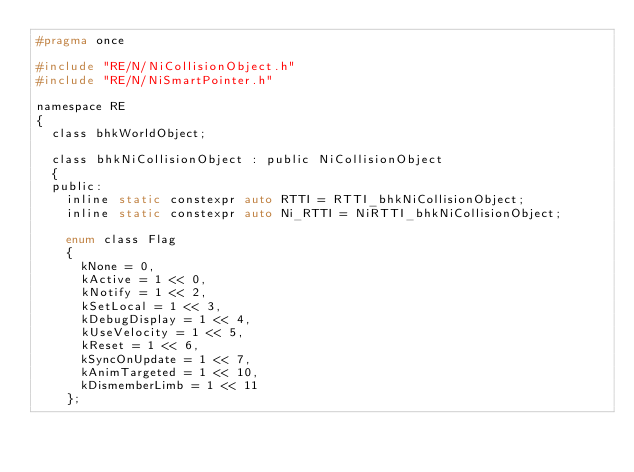<code> <loc_0><loc_0><loc_500><loc_500><_C_>#pragma once

#include "RE/N/NiCollisionObject.h"
#include "RE/N/NiSmartPointer.h"

namespace RE
{
	class bhkWorldObject;

	class bhkNiCollisionObject : public NiCollisionObject
	{
	public:
		inline static constexpr auto RTTI = RTTI_bhkNiCollisionObject;
		inline static constexpr auto Ni_RTTI = NiRTTI_bhkNiCollisionObject;

		enum class Flag
		{
			kNone = 0,
			kActive = 1 << 0,
			kNotify = 1 << 2,
			kSetLocal = 1 << 3,
			kDebugDisplay = 1 << 4,
			kUseVelocity = 1 << 5,
			kReset = 1 << 6,
			kSyncOnUpdate = 1 << 7,
			kAnimTargeted = 1 << 10,
			kDismemberLimb = 1 << 11
		};
</code> 